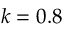<formula> <loc_0><loc_0><loc_500><loc_500>k = 0 . 8</formula> 